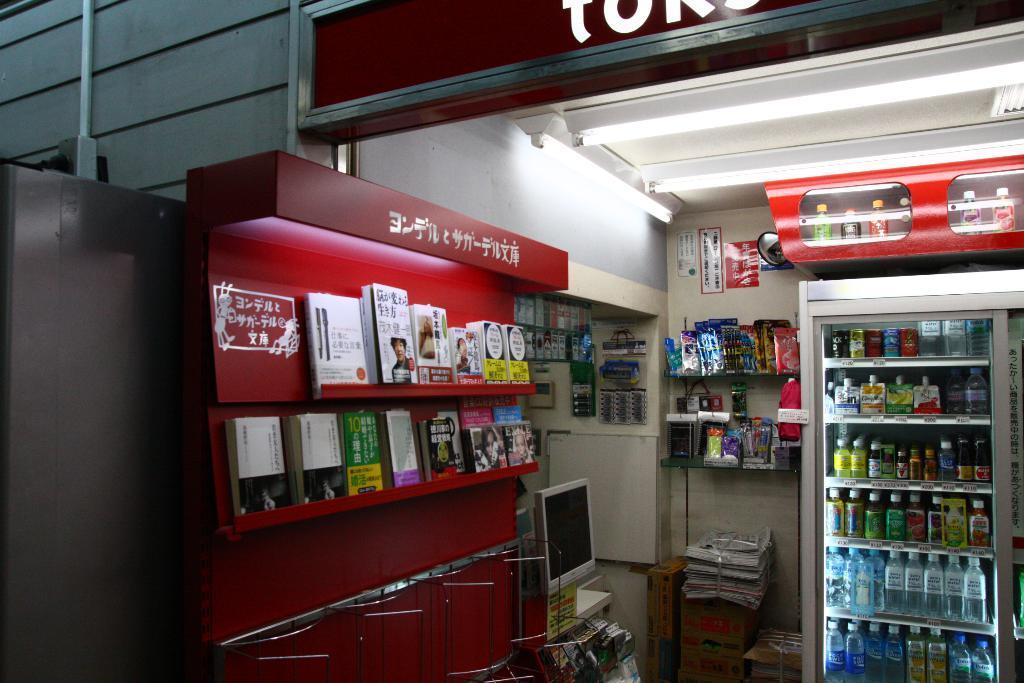Please provide a concise description of this image. In this picture I can observe a refrigerator in which drinks and water bottles are placed on the right side. In the middle of the picture I can observe some books. In the top of the picture I can observe tube lights. In the bottom of the picture I can observe monitor. 